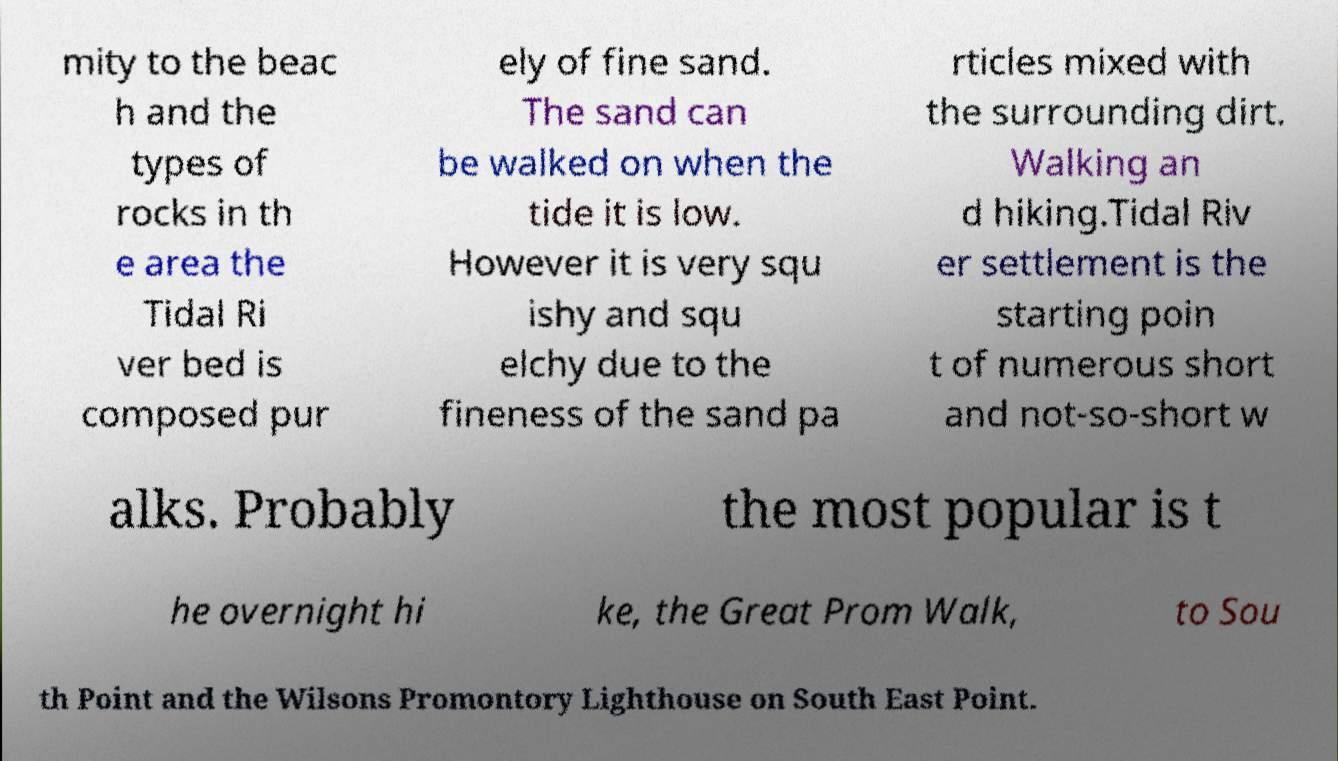There's text embedded in this image that I need extracted. Can you transcribe it verbatim? mity to the beac h and the types of rocks in th e area the Tidal Ri ver bed is composed pur ely of fine sand. The sand can be walked on when the tide it is low. However it is very squ ishy and squ elchy due to the fineness of the sand pa rticles mixed with the surrounding dirt. Walking an d hiking.Tidal Riv er settlement is the starting poin t of numerous short and not-so-short w alks. Probably the most popular is t he overnight hi ke, the Great Prom Walk, to Sou th Point and the Wilsons Promontory Lighthouse on South East Point. 